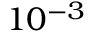Convert formula to latex. <formula><loc_0><loc_0><loc_500><loc_500>1 0 ^ { - 3 }</formula> 